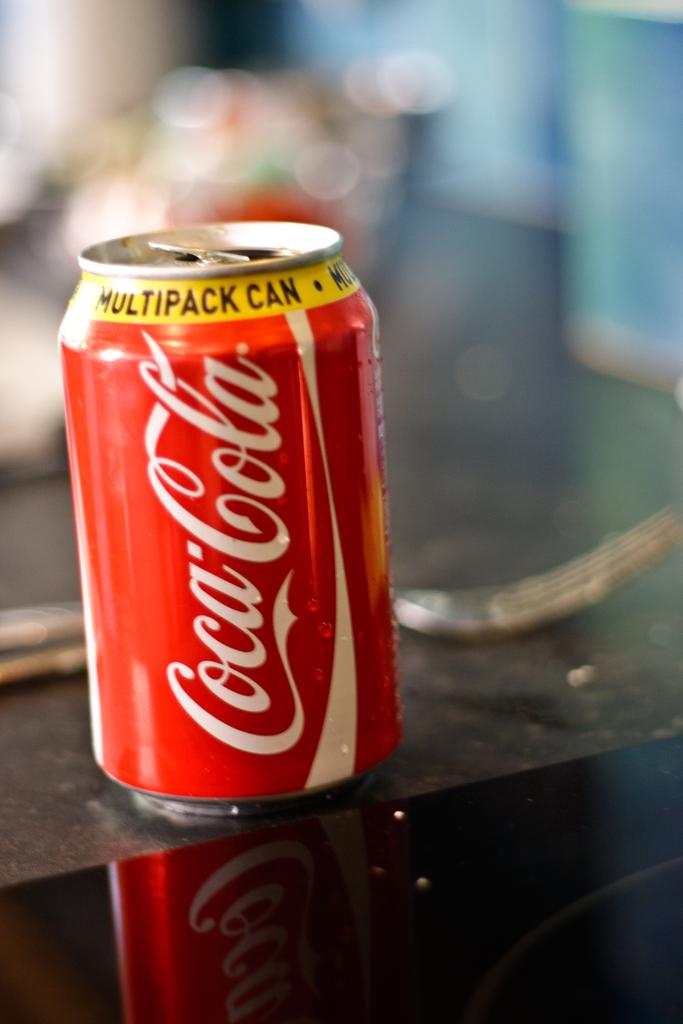<image>
Summarize the visual content of the image. A can of Coca-Cola says it came from a multipack can. 